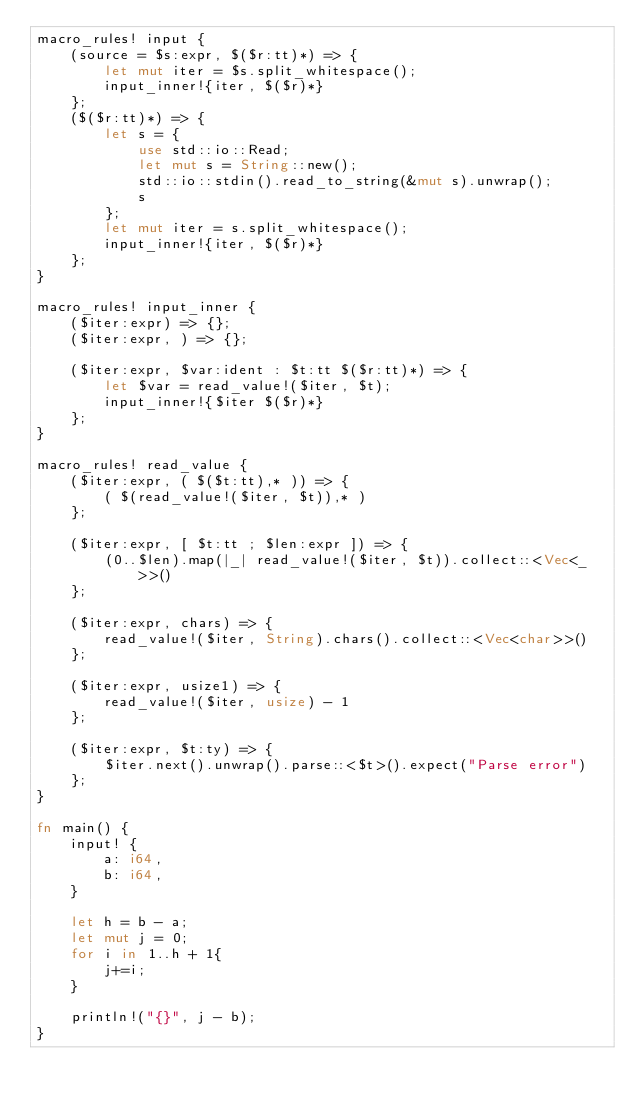<code> <loc_0><loc_0><loc_500><loc_500><_Rust_>macro_rules! input {
    (source = $s:expr, $($r:tt)*) => {
        let mut iter = $s.split_whitespace();
        input_inner!{iter, $($r)*}
    };
    ($($r:tt)*) => {
        let s = {
            use std::io::Read;
            let mut s = String::new();
            std::io::stdin().read_to_string(&mut s).unwrap();
            s
        };
        let mut iter = s.split_whitespace();
        input_inner!{iter, $($r)*}
    };
}

macro_rules! input_inner {
    ($iter:expr) => {};
    ($iter:expr, ) => {};

    ($iter:expr, $var:ident : $t:tt $($r:tt)*) => {
        let $var = read_value!($iter, $t);
        input_inner!{$iter $($r)*}
    };
}

macro_rules! read_value {
    ($iter:expr, ( $($t:tt),* )) => {
        ( $(read_value!($iter, $t)),* )
    };

    ($iter:expr, [ $t:tt ; $len:expr ]) => {
        (0..$len).map(|_| read_value!($iter, $t)).collect::<Vec<_>>()
    };

    ($iter:expr, chars) => {
        read_value!($iter, String).chars().collect::<Vec<char>>()
    };

    ($iter:expr, usize1) => {
        read_value!($iter, usize) - 1
    };

    ($iter:expr, $t:ty) => {
        $iter.next().unwrap().parse::<$t>().expect("Parse error")
    };
}

fn main() {
    input! {
        a: i64,
        b: i64,
    }

    let h = b - a;
    let mut j = 0;
    for i in 1..h + 1{
        j+=i;
    }

    println!("{}", j - b);
}</code> 